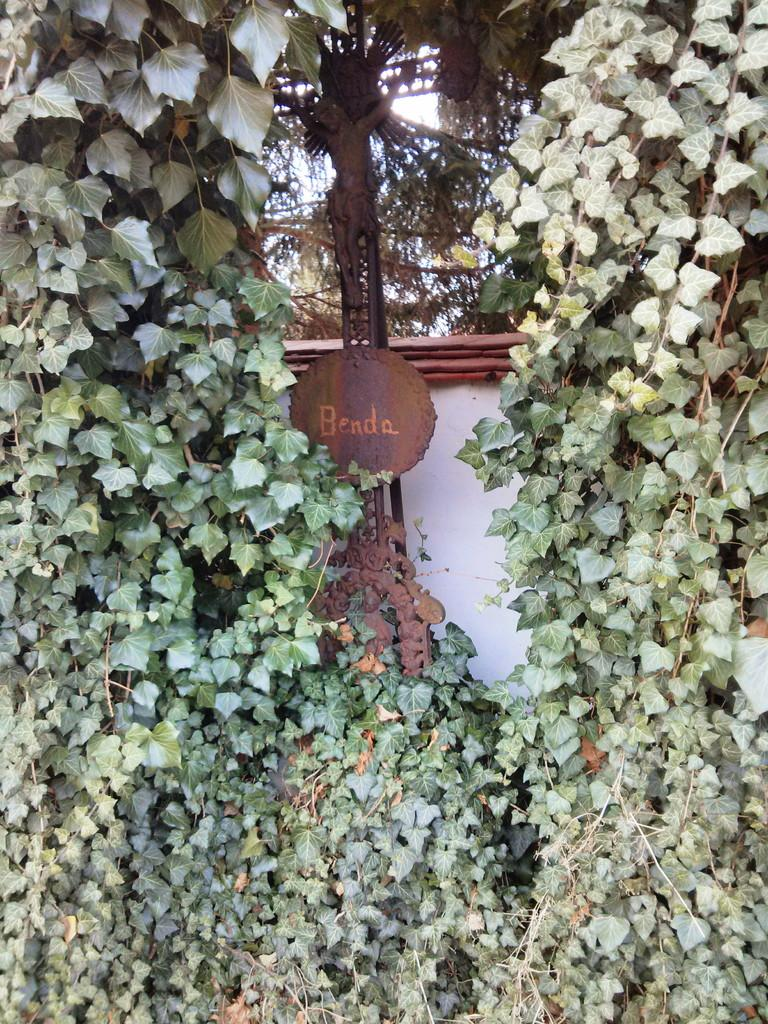What is the main subject in the image? There is a statue in the image. What is written or displayed on the metal pole? There is a board with text on a metal pole in the image. What type of vegetation can be seen in the image? There is a group of plants and trees in the image. What type of structure is visible in the image? There is a wall in the image. What part of the natural environment is visible in the image? A: The sky is visible in the image. How many beads are hanging from the statue in the image? There are no beads hanging from the statue in the image. What type of punishment is being administered to the trees in the image? There is no punishment being administered to the trees in the image; they are simply standing in the background. 